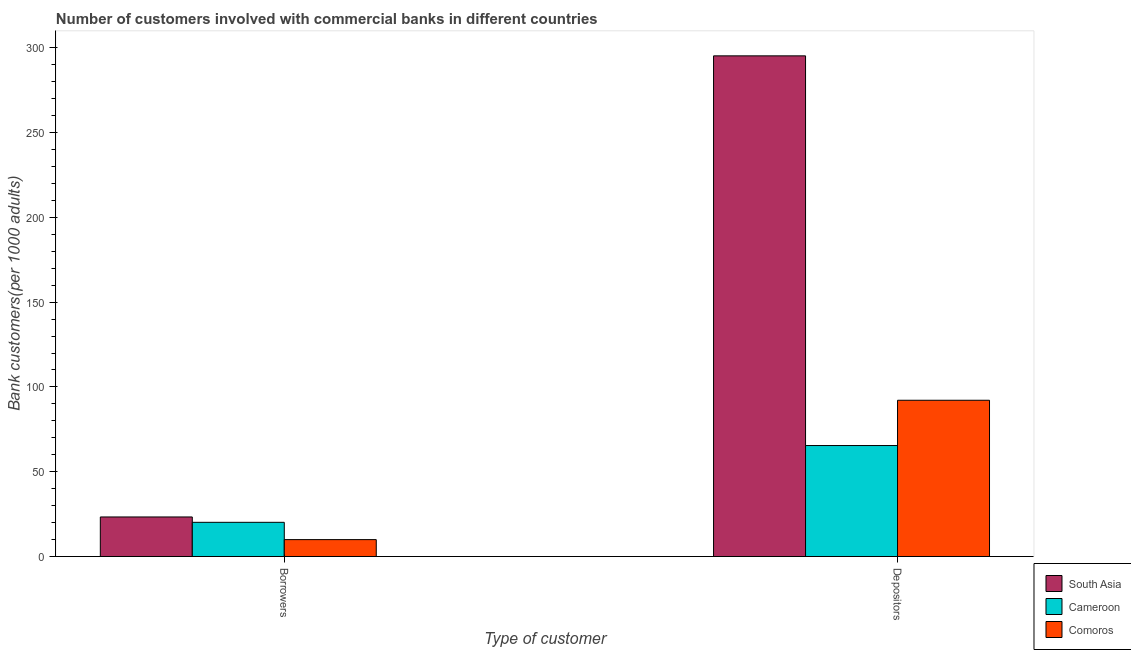How many different coloured bars are there?
Give a very brief answer. 3. How many groups of bars are there?
Give a very brief answer. 2. Are the number of bars on each tick of the X-axis equal?
Offer a terse response. Yes. How many bars are there on the 2nd tick from the right?
Your answer should be very brief. 3. What is the label of the 2nd group of bars from the left?
Provide a short and direct response. Depositors. What is the number of borrowers in South Asia?
Offer a very short reply. 23.34. Across all countries, what is the maximum number of borrowers?
Give a very brief answer. 23.34. Across all countries, what is the minimum number of borrowers?
Provide a succinct answer. 9.98. In which country was the number of borrowers maximum?
Ensure brevity in your answer.  South Asia. In which country was the number of depositors minimum?
Provide a succinct answer. Cameroon. What is the total number of depositors in the graph?
Give a very brief answer. 452.83. What is the difference between the number of borrowers in Comoros and that in South Asia?
Provide a succinct answer. -13.36. What is the difference between the number of borrowers in South Asia and the number of depositors in Comoros?
Your response must be concise. -68.81. What is the average number of borrowers per country?
Make the answer very short. 17.83. What is the difference between the number of borrowers and number of depositors in South Asia?
Keep it short and to the point. -271.89. In how many countries, is the number of borrowers greater than 40 ?
Make the answer very short. 0. What is the ratio of the number of borrowers in South Asia to that in Cameroon?
Ensure brevity in your answer.  1.16. Is the number of borrowers in Comoros less than that in Cameroon?
Provide a short and direct response. Yes. In how many countries, is the number of depositors greater than the average number of depositors taken over all countries?
Your response must be concise. 1. What does the 2nd bar from the left in Depositors represents?
Ensure brevity in your answer.  Cameroon. What does the 1st bar from the right in Borrowers represents?
Keep it short and to the point. Comoros. How many bars are there?
Provide a succinct answer. 6. Where does the legend appear in the graph?
Keep it short and to the point. Bottom right. What is the title of the graph?
Give a very brief answer. Number of customers involved with commercial banks in different countries. Does "El Salvador" appear as one of the legend labels in the graph?
Provide a succinct answer. No. What is the label or title of the X-axis?
Your answer should be compact. Type of customer. What is the label or title of the Y-axis?
Ensure brevity in your answer.  Bank customers(per 1000 adults). What is the Bank customers(per 1000 adults) of South Asia in Borrowers?
Your response must be concise. 23.34. What is the Bank customers(per 1000 adults) of Cameroon in Borrowers?
Make the answer very short. 20.18. What is the Bank customers(per 1000 adults) of Comoros in Borrowers?
Make the answer very short. 9.98. What is the Bank customers(per 1000 adults) of South Asia in Depositors?
Ensure brevity in your answer.  295.23. What is the Bank customers(per 1000 adults) of Cameroon in Depositors?
Your answer should be very brief. 65.45. What is the Bank customers(per 1000 adults) of Comoros in Depositors?
Your answer should be compact. 92.15. Across all Type of customer, what is the maximum Bank customers(per 1000 adults) in South Asia?
Make the answer very short. 295.23. Across all Type of customer, what is the maximum Bank customers(per 1000 adults) in Cameroon?
Your answer should be compact. 65.45. Across all Type of customer, what is the maximum Bank customers(per 1000 adults) in Comoros?
Offer a very short reply. 92.15. Across all Type of customer, what is the minimum Bank customers(per 1000 adults) in South Asia?
Make the answer very short. 23.34. Across all Type of customer, what is the minimum Bank customers(per 1000 adults) of Cameroon?
Provide a short and direct response. 20.18. Across all Type of customer, what is the minimum Bank customers(per 1000 adults) of Comoros?
Offer a terse response. 9.98. What is the total Bank customers(per 1000 adults) of South Asia in the graph?
Keep it short and to the point. 318.57. What is the total Bank customers(per 1000 adults) in Cameroon in the graph?
Provide a succinct answer. 85.63. What is the total Bank customers(per 1000 adults) of Comoros in the graph?
Provide a succinct answer. 102.13. What is the difference between the Bank customers(per 1000 adults) of South Asia in Borrowers and that in Depositors?
Your response must be concise. -271.89. What is the difference between the Bank customers(per 1000 adults) in Cameroon in Borrowers and that in Depositors?
Ensure brevity in your answer.  -45.27. What is the difference between the Bank customers(per 1000 adults) of Comoros in Borrowers and that in Depositors?
Your answer should be compact. -82.17. What is the difference between the Bank customers(per 1000 adults) of South Asia in Borrowers and the Bank customers(per 1000 adults) of Cameroon in Depositors?
Offer a terse response. -42.11. What is the difference between the Bank customers(per 1000 adults) of South Asia in Borrowers and the Bank customers(per 1000 adults) of Comoros in Depositors?
Your answer should be very brief. -68.81. What is the difference between the Bank customers(per 1000 adults) of Cameroon in Borrowers and the Bank customers(per 1000 adults) of Comoros in Depositors?
Keep it short and to the point. -71.97. What is the average Bank customers(per 1000 adults) of South Asia per Type of customer?
Offer a very short reply. 159.29. What is the average Bank customers(per 1000 adults) of Cameroon per Type of customer?
Give a very brief answer. 42.82. What is the average Bank customers(per 1000 adults) of Comoros per Type of customer?
Offer a terse response. 51.06. What is the difference between the Bank customers(per 1000 adults) in South Asia and Bank customers(per 1000 adults) in Cameroon in Borrowers?
Make the answer very short. 3.16. What is the difference between the Bank customers(per 1000 adults) of South Asia and Bank customers(per 1000 adults) of Comoros in Borrowers?
Your answer should be very brief. 13.36. What is the difference between the Bank customers(per 1000 adults) in Cameroon and Bank customers(per 1000 adults) in Comoros in Borrowers?
Provide a short and direct response. 10.2. What is the difference between the Bank customers(per 1000 adults) of South Asia and Bank customers(per 1000 adults) of Cameroon in Depositors?
Provide a succinct answer. 229.78. What is the difference between the Bank customers(per 1000 adults) of South Asia and Bank customers(per 1000 adults) of Comoros in Depositors?
Your answer should be compact. 203.08. What is the difference between the Bank customers(per 1000 adults) in Cameroon and Bank customers(per 1000 adults) in Comoros in Depositors?
Ensure brevity in your answer.  -26.7. What is the ratio of the Bank customers(per 1000 adults) of South Asia in Borrowers to that in Depositors?
Offer a terse response. 0.08. What is the ratio of the Bank customers(per 1000 adults) of Cameroon in Borrowers to that in Depositors?
Offer a very short reply. 0.31. What is the ratio of the Bank customers(per 1000 adults) in Comoros in Borrowers to that in Depositors?
Your answer should be compact. 0.11. What is the difference between the highest and the second highest Bank customers(per 1000 adults) of South Asia?
Ensure brevity in your answer.  271.89. What is the difference between the highest and the second highest Bank customers(per 1000 adults) of Cameroon?
Offer a terse response. 45.27. What is the difference between the highest and the second highest Bank customers(per 1000 adults) in Comoros?
Your response must be concise. 82.17. What is the difference between the highest and the lowest Bank customers(per 1000 adults) in South Asia?
Provide a short and direct response. 271.89. What is the difference between the highest and the lowest Bank customers(per 1000 adults) in Cameroon?
Your response must be concise. 45.27. What is the difference between the highest and the lowest Bank customers(per 1000 adults) in Comoros?
Make the answer very short. 82.17. 